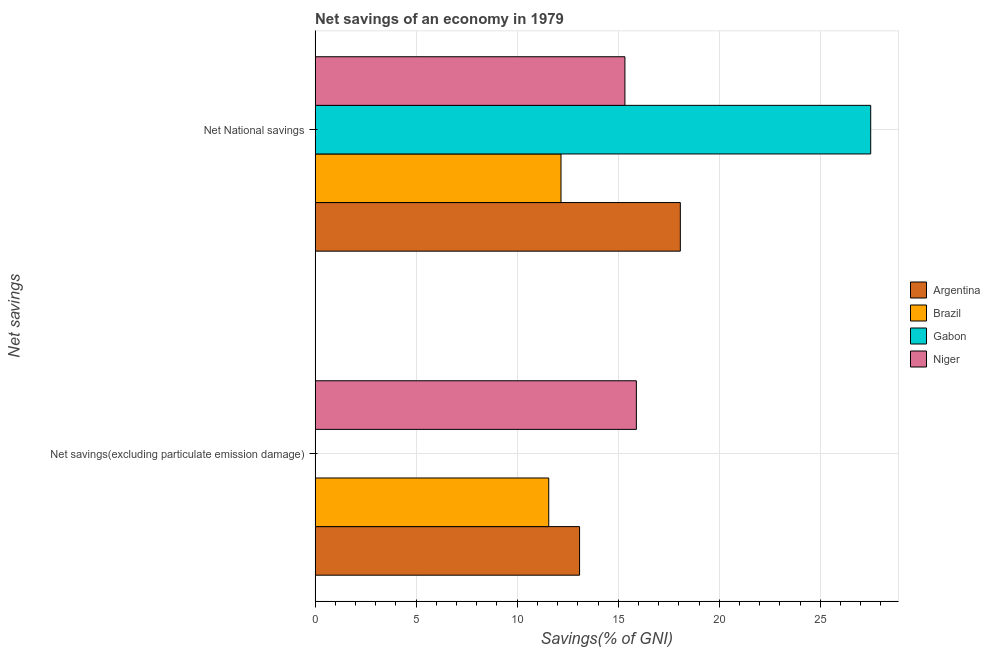How many different coloured bars are there?
Provide a succinct answer. 4. How many bars are there on the 2nd tick from the top?
Your response must be concise. 3. What is the label of the 2nd group of bars from the top?
Offer a terse response. Net savings(excluding particulate emission damage). What is the net savings(excluding particulate emission damage) in Gabon?
Your response must be concise. 0. Across all countries, what is the maximum net savings(excluding particulate emission damage)?
Provide a short and direct response. 15.9. Across all countries, what is the minimum net national savings?
Keep it short and to the point. 12.17. In which country was the net savings(excluding particulate emission damage) maximum?
Provide a short and direct response. Niger. What is the total net national savings in the graph?
Give a very brief answer. 73.07. What is the difference between the net national savings in Argentina and that in Brazil?
Keep it short and to the point. 5.91. What is the difference between the net savings(excluding particulate emission damage) in Niger and the net national savings in Argentina?
Provide a succinct answer. -2.18. What is the average net national savings per country?
Provide a succinct answer. 18.27. What is the difference between the net savings(excluding particulate emission damage) and net national savings in Brazil?
Your answer should be very brief. -0.61. What is the ratio of the net savings(excluding particulate emission damage) in Niger to that in Brazil?
Offer a very short reply. 1.37. In how many countries, is the net savings(excluding particulate emission damage) greater than the average net savings(excluding particulate emission damage) taken over all countries?
Ensure brevity in your answer.  3. How many bars are there?
Keep it short and to the point. 7. Are all the bars in the graph horizontal?
Ensure brevity in your answer.  Yes. What is the difference between two consecutive major ticks on the X-axis?
Give a very brief answer. 5. Are the values on the major ticks of X-axis written in scientific E-notation?
Keep it short and to the point. No. Where does the legend appear in the graph?
Ensure brevity in your answer.  Center right. How are the legend labels stacked?
Provide a succinct answer. Vertical. What is the title of the graph?
Ensure brevity in your answer.  Net savings of an economy in 1979. What is the label or title of the X-axis?
Your response must be concise. Savings(% of GNI). What is the label or title of the Y-axis?
Ensure brevity in your answer.  Net savings. What is the Savings(% of GNI) in Argentina in Net savings(excluding particulate emission damage)?
Your answer should be very brief. 13.09. What is the Savings(% of GNI) of Brazil in Net savings(excluding particulate emission damage)?
Ensure brevity in your answer.  11.56. What is the Savings(% of GNI) in Gabon in Net savings(excluding particulate emission damage)?
Your answer should be very brief. 0. What is the Savings(% of GNI) of Niger in Net savings(excluding particulate emission damage)?
Keep it short and to the point. 15.9. What is the Savings(% of GNI) in Argentina in Net National savings?
Your answer should be very brief. 18.07. What is the Savings(% of GNI) of Brazil in Net National savings?
Your answer should be compact. 12.17. What is the Savings(% of GNI) in Gabon in Net National savings?
Provide a succinct answer. 27.49. What is the Savings(% of GNI) in Niger in Net National savings?
Provide a succinct answer. 15.33. Across all Net savings, what is the maximum Savings(% of GNI) of Argentina?
Your answer should be very brief. 18.07. Across all Net savings, what is the maximum Savings(% of GNI) in Brazil?
Provide a succinct answer. 12.17. Across all Net savings, what is the maximum Savings(% of GNI) in Gabon?
Your answer should be compact. 27.49. Across all Net savings, what is the maximum Savings(% of GNI) of Niger?
Provide a succinct answer. 15.9. Across all Net savings, what is the minimum Savings(% of GNI) of Argentina?
Give a very brief answer. 13.09. Across all Net savings, what is the minimum Savings(% of GNI) in Brazil?
Your response must be concise. 11.56. Across all Net savings, what is the minimum Savings(% of GNI) in Niger?
Your answer should be very brief. 15.33. What is the total Savings(% of GNI) of Argentina in the graph?
Give a very brief answer. 31.16. What is the total Savings(% of GNI) of Brazil in the graph?
Your answer should be compact. 23.73. What is the total Savings(% of GNI) of Gabon in the graph?
Your response must be concise. 27.49. What is the total Savings(% of GNI) of Niger in the graph?
Provide a succinct answer. 31.23. What is the difference between the Savings(% of GNI) in Argentina in Net savings(excluding particulate emission damage) and that in Net National savings?
Your answer should be very brief. -4.99. What is the difference between the Savings(% of GNI) of Brazil in Net savings(excluding particulate emission damage) and that in Net National savings?
Make the answer very short. -0.61. What is the difference between the Savings(% of GNI) of Niger in Net savings(excluding particulate emission damage) and that in Net National savings?
Keep it short and to the point. 0.57. What is the difference between the Savings(% of GNI) in Argentina in Net savings(excluding particulate emission damage) and the Savings(% of GNI) in Brazil in Net National savings?
Your answer should be compact. 0.92. What is the difference between the Savings(% of GNI) in Argentina in Net savings(excluding particulate emission damage) and the Savings(% of GNI) in Gabon in Net National savings?
Make the answer very short. -14.41. What is the difference between the Savings(% of GNI) of Argentina in Net savings(excluding particulate emission damage) and the Savings(% of GNI) of Niger in Net National savings?
Offer a very short reply. -2.24. What is the difference between the Savings(% of GNI) of Brazil in Net savings(excluding particulate emission damage) and the Savings(% of GNI) of Gabon in Net National savings?
Offer a terse response. -15.93. What is the difference between the Savings(% of GNI) in Brazil in Net savings(excluding particulate emission damage) and the Savings(% of GNI) in Niger in Net National savings?
Give a very brief answer. -3.77. What is the average Savings(% of GNI) in Argentina per Net savings?
Your response must be concise. 15.58. What is the average Savings(% of GNI) in Brazil per Net savings?
Your response must be concise. 11.87. What is the average Savings(% of GNI) of Gabon per Net savings?
Provide a short and direct response. 13.75. What is the average Savings(% of GNI) of Niger per Net savings?
Ensure brevity in your answer.  15.62. What is the difference between the Savings(% of GNI) in Argentina and Savings(% of GNI) in Brazil in Net savings(excluding particulate emission damage)?
Keep it short and to the point. 1.53. What is the difference between the Savings(% of GNI) of Argentina and Savings(% of GNI) of Niger in Net savings(excluding particulate emission damage)?
Give a very brief answer. -2.81. What is the difference between the Savings(% of GNI) in Brazil and Savings(% of GNI) in Niger in Net savings(excluding particulate emission damage)?
Offer a terse response. -4.34. What is the difference between the Savings(% of GNI) of Argentina and Savings(% of GNI) of Brazil in Net National savings?
Give a very brief answer. 5.91. What is the difference between the Savings(% of GNI) of Argentina and Savings(% of GNI) of Gabon in Net National savings?
Provide a short and direct response. -9.42. What is the difference between the Savings(% of GNI) in Argentina and Savings(% of GNI) in Niger in Net National savings?
Ensure brevity in your answer.  2.74. What is the difference between the Savings(% of GNI) in Brazil and Savings(% of GNI) in Gabon in Net National savings?
Provide a short and direct response. -15.33. What is the difference between the Savings(% of GNI) in Brazil and Savings(% of GNI) in Niger in Net National savings?
Make the answer very short. -3.16. What is the difference between the Savings(% of GNI) in Gabon and Savings(% of GNI) in Niger in Net National savings?
Provide a short and direct response. 12.16. What is the ratio of the Savings(% of GNI) in Argentina in Net savings(excluding particulate emission damage) to that in Net National savings?
Your answer should be compact. 0.72. What is the ratio of the Savings(% of GNI) of Brazil in Net savings(excluding particulate emission damage) to that in Net National savings?
Provide a succinct answer. 0.95. What is the difference between the highest and the second highest Savings(% of GNI) of Argentina?
Your response must be concise. 4.99. What is the difference between the highest and the second highest Savings(% of GNI) in Brazil?
Ensure brevity in your answer.  0.61. What is the difference between the highest and the second highest Savings(% of GNI) of Niger?
Keep it short and to the point. 0.57. What is the difference between the highest and the lowest Savings(% of GNI) of Argentina?
Provide a short and direct response. 4.99. What is the difference between the highest and the lowest Savings(% of GNI) of Brazil?
Your answer should be compact. 0.61. What is the difference between the highest and the lowest Savings(% of GNI) of Gabon?
Offer a very short reply. 27.49. What is the difference between the highest and the lowest Savings(% of GNI) of Niger?
Make the answer very short. 0.57. 